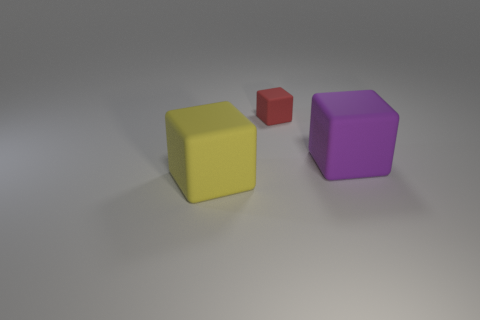Subtract all red cubes. How many cubes are left? 2 Add 1 tiny red cylinders. How many objects exist? 4 Subtract 0 brown cylinders. How many objects are left? 3 Subtract all tiny cyan shiny cylinders. Subtract all yellow rubber things. How many objects are left? 2 Add 2 big yellow objects. How many big yellow objects are left? 3 Add 1 purple cylinders. How many purple cylinders exist? 1 